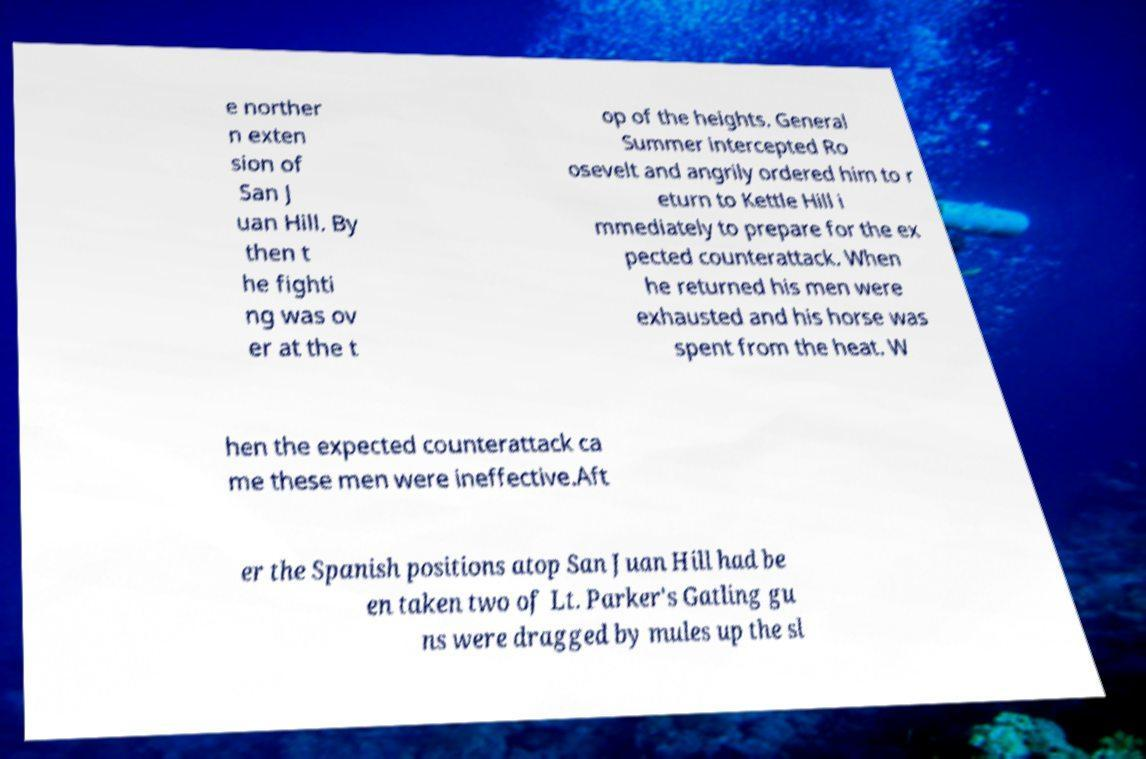Could you assist in decoding the text presented in this image and type it out clearly? e norther n exten sion of San J uan Hill. By then t he fighti ng was ov er at the t op of the heights. General Summer intercepted Ro osevelt and angrily ordered him to r eturn to Kettle Hill i mmediately to prepare for the ex pected counterattack. When he returned his men were exhausted and his horse was spent from the heat. W hen the expected counterattack ca me these men were ineffective.Aft er the Spanish positions atop San Juan Hill had be en taken two of Lt. Parker's Gatling gu ns were dragged by mules up the sl 